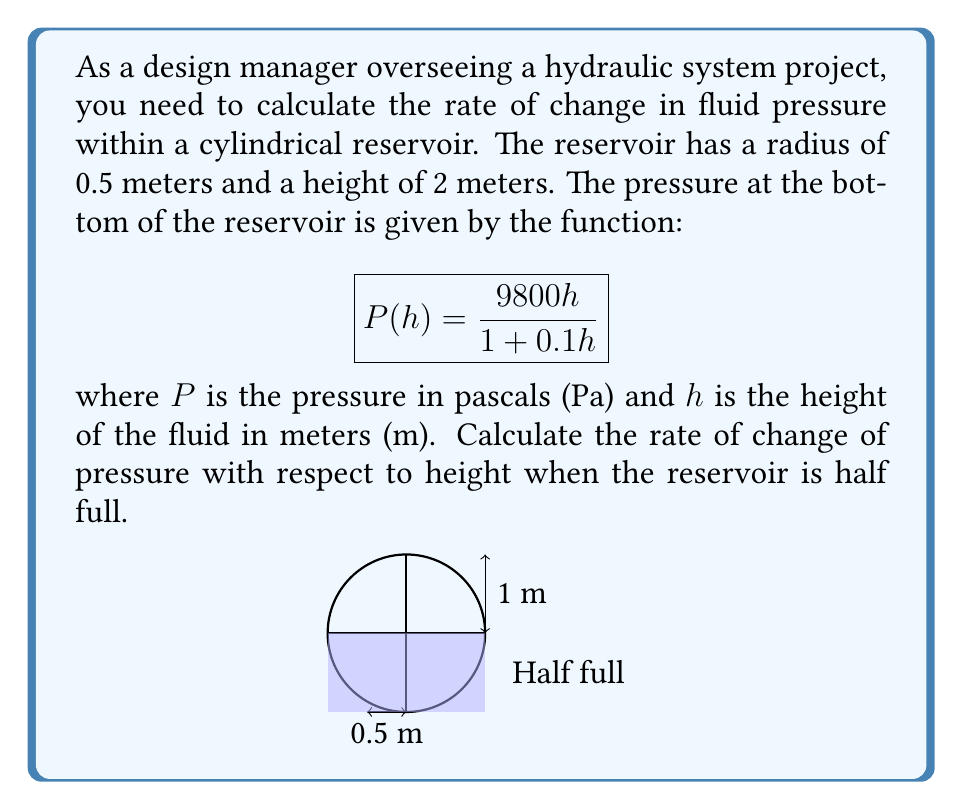Can you solve this math problem? To solve this problem, we need to follow these steps:

1) The rate of change of pressure with respect to height is given by the derivative of the pressure function $P(h)$ with respect to $h$.

2) Let's find $\frac{dP}{dh}$ using the quotient rule:

   $$\frac{dP}{dh} = \frac{(1 + 0.1h) \cdot 9800 - 9800h \cdot 0.1}{(1 + 0.1h)^2}$$

3) Simplify:

   $$\frac{dP}{dh} = \frac{9800 + 980h - 980h}{(1 + 0.1h)^2} = \frac{9800}{(1 + 0.1h)^2}$$

4) The reservoir is half full when $h = 1$ meter (half of the total height of 2 meters).

5) Substitute $h = 1$ into our derivative:

   $$\frac{dP}{dh}\bigg|_{h=1} = \frac{9800}{(1 + 0.1(1))^2} = \frac{9800}{(1.1)^2} = \frac{9800}{1.21}$$

6) Calculate the final value:

   $$\frac{dP}{dh}\bigg|_{h=1} = 8099.17 \text{ Pa/m}$$
Answer: $8099.17 \text{ Pa/m}$ 